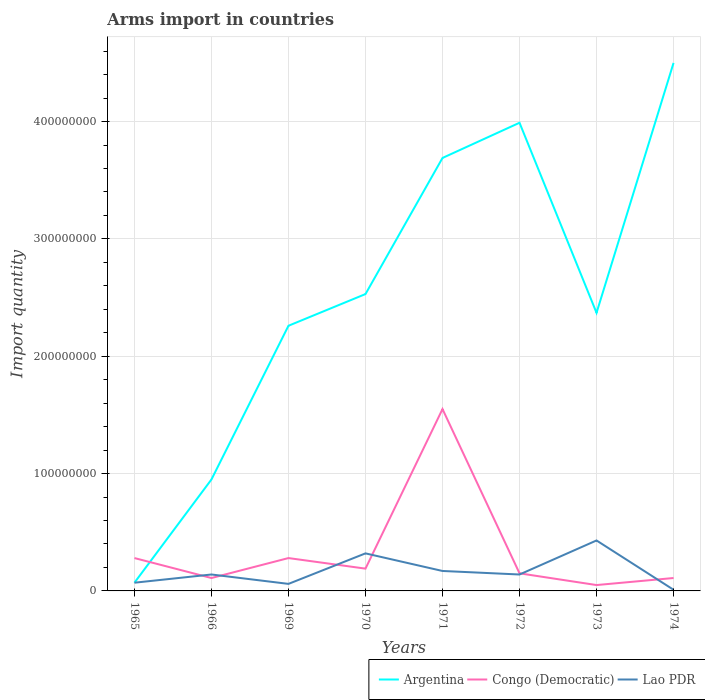Across all years, what is the maximum total arms import in Argentina?
Your answer should be very brief. 7.00e+06. In which year was the total arms import in Argentina maximum?
Your response must be concise. 1965. What is the total total arms import in Lao PDR in the graph?
Provide a succinct answer. -1.10e+07. What is the difference between the highest and the second highest total arms import in Argentina?
Provide a short and direct response. 4.43e+08. What is the difference between the highest and the lowest total arms import in Argentina?
Your answer should be very brief. 3. Is the total arms import in Congo (Democratic) strictly greater than the total arms import in Lao PDR over the years?
Your answer should be very brief. No. How many lines are there?
Offer a terse response. 3. How many years are there in the graph?
Your response must be concise. 8. What is the difference between two consecutive major ticks on the Y-axis?
Offer a terse response. 1.00e+08. Are the values on the major ticks of Y-axis written in scientific E-notation?
Your response must be concise. No. Where does the legend appear in the graph?
Offer a very short reply. Bottom right. What is the title of the graph?
Give a very brief answer. Arms import in countries. Does "Algeria" appear as one of the legend labels in the graph?
Provide a succinct answer. No. What is the label or title of the X-axis?
Offer a terse response. Years. What is the label or title of the Y-axis?
Ensure brevity in your answer.  Import quantity. What is the Import quantity in Congo (Democratic) in 1965?
Ensure brevity in your answer.  2.80e+07. What is the Import quantity in Argentina in 1966?
Offer a terse response. 9.50e+07. What is the Import quantity of Congo (Democratic) in 1966?
Your answer should be compact. 1.10e+07. What is the Import quantity of Lao PDR in 1966?
Your answer should be very brief. 1.40e+07. What is the Import quantity in Argentina in 1969?
Your response must be concise. 2.26e+08. What is the Import quantity of Congo (Democratic) in 1969?
Ensure brevity in your answer.  2.80e+07. What is the Import quantity of Lao PDR in 1969?
Your answer should be compact. 6.00e+06. What is the Import quantity in Argentina in 1970?
Provide a succinct answer. 2.53e+08. What is the Import quantity in Congo (Democratic) in 1970?
Your answer should be very brief. 1.90e+07. What is the Import quantity of Lao PDR in 1970?
Your response must be concise. 3.20e+07. What is the Import quantity in Argentina in 1971?
Offer a very short reply. 3.69e+08. What is the Import quantity in Congo (Democratic) in 1971?
Provide a succinct answer. 1.55e+08. What is the Import quantity of Lao PDR in 1971?
Your response must be concise. 1.70e+07. What is the Import quantity of Argentina in 1972?
Provide a short and direct response. 3.99e+08. What is the Import quantity in Congo (Democratic) in 1972?
Ensure brevity in your answer.  1.50e+07. What is the Import quantity in Lao PDR in 1972?
Keep it short and to the point. 1.40e+07. What is the Import quantity of Argentina in 1973?
Make the answer very short. 2.37e+08. What is the Import quantity in Congo (Democratic) in 1973?
Offer a very short reply. 5.00e+06. What is the Import quantity of Lao PDR in 1973?
Your answer should be very brief. 4.30e+07. What is the Import quantity in Argentina in 1974?
Ensure brevity in your answer.  4.50e+08. What is the Import quantity of Congo (Democratic) in 1974?
Make the answer very short. 1.10e+07. Across all years, what is the maximum Import quantity in Argentina?
Offer a terse response. 4.50e+08. Across all years, what is the maximum Import quantity of Congo (Democratic)?
Your answer should be compact. 1.55e+08. Across all years, what is the maximum Import quantity of Lao PDR?
Your answer should be compact. 4.30e+07. Across all years, what is the minimum Import quantity in Argentina?
Offer a terse response. 7.00e+06. Across all years, what is the minimum Import quantity in Congo (Democratic)?
Offer a very short reply. 5.00e+06. Across all years, what is the minimum Import quantity in Lao PDR?
Give a very brief answer. 1.00e+06. What is the total Import quantity in Argentina in the graph?
Offer a very short reply. 2.04e+09. What is the total Import quantity in Congo (Democratic) in the graph?
Offer a very short reply. 2.72e+08. What is the total Import quantity of Lao PDR in the graph?
Provide a succinct answer. 1.34e+08. What is the difference between the Import quantity of Argentina in 1965 and that in 1966?
Offer a very short reply. -8.80e+07. What is the difference between the Import quantity in Congo (Democratic) in 1965 and that in 1966?
Offer a very short reply. 1.70e+07. What is the difference between the Import quantity in Lao PDR in 1965 and that in 1966?
Offer a terse response. -7.00e+06. What is the difference between the Import quantity in Argentina in 1965 and that in 1969?
Your response must be concise. -2.19e+08. What is the difference between the Import quantity in Lao PDR in 1965 and that in 1969?
Give a very brief answer. 1.00e+06. What is the difference between the Import quantity in Argentina in 1965 and that in 1970?
Your answer should be very brief. -2.46e+08. What is the difference between the Import quantity of Congo (Democratic) in 1965 and that in 1970?
Offer a very short reply. 9.00e+06. What is the difference between the Import quantity of Lao PDR in 1965 and that in 1970?
Your answer should be compact. -2.50e+07. What is the difference between the Import quantity of Argentina in 1965 and that in 1971?
Provide a succinct answer. -3.62e+08. What is the difference between the Import quantity in Congo (Democratic) in 1965 and that in 1971?
Provide a succinct answer. -1.27e+08. What is the difference between the Import quantity in Lao PDR in 1965 and that in 1971?
Your answer should be very brief. -1.00e+07. What is the difference between the Import quantity of Argentina in 1965 and that in 1972?
Offer a very short reply. -3.92e+08. What is the difference between the Import quantity of Congo (Democratic) in 1965 and that in 1972?
Your answer should be very brief. 1.30e+07. What is the difference between the Import quantity of Lao PDR in 1965 and that in 1972?
Your answer should be very brief. -7.00e+06. What is the difference between the Import quantity in Argentina in 1965 and that in 1973?
Your answer should be very brief. -2.30e+08. What is the difference between the Import quantity of Congo (Democratic) in 1965 and that in 1973?
Your answer should be compact. 2.30e+07. What is the difference between the Import quantity in Lao PDR in 1965 and that in 1973?
Offer a very short reply. -3.60e+07. What is the difference between the Import quantity in Argentina in 1965 and that in 1974?
Provide a short and direct response. -4.43e+08. What is the difference between the Import quantity in Congo (Democratic) in 1965 and that in 1974?
Your answer should be compact. 1.70e+07. What is the difference between the Import quantity in Argentina in 1966 and that in 1969?
Give a very brief answer. -1.31e+08. What is the difference between the Import quantity of Congo (Democratic) in 1966 and that in 1969?
Your answer should be very brief. -1.70e+07. What is the difference between the Import quantity of Lao PDR in 1966 and that in 1969?
Give a very brief answer. 8.00e+06. What is the difference between the Import quantity of Argentina in 1966 and that in 1970?
Give a very brief answer. -1.58e+08. What is the difference between the Import quantity of Congo (Democratic) in 1966 and that in 1970?
Your answer should be compact. -8.00e+06. What is the difference between the Import quantity in Lao PDR in 1966 and that in 1970?
Give a very brief answer. -1.80e+07. What is the difference between the Import quantity in Argentina in 1966 and that in 1971?
Make the answer very short. -2.74e+08. What is the difference between the Import quantity of Congo (Democratic) in 1966 and that in 1971?
Make the answer very short. -1.44e+08. What is the difference between the Import quantity in Argentina in 1966 and that in 1972?
Offer a terse response. -3.04e+08. What is the difference between the Import quantity in Congo (Democratic) in 1966 and that in 1972?
Your answer should be very brief. -4.00e+06. What is the difference between the Import quantity of Argentina in 1966 and that in 1973?
Make the answer very short. -1.42e+08. What is the difference between the Import quantity in Congo (Democratic) in 1966 and that in 1973?
Make the answer very short. 6.00e+06. What is the difference between the Import quantity of Lao PDR in 1966 and that in 1973?
Provide a succinct answer. -2.90e+07. What is the difference between the Import quantity in Argentina in 1966 and that in 1974?
Your answer should be very brief. -3.55e+08. What is the difference between the Import quantity of Congo (Democratic) in 1966 and that in 1974?
Your answer should be very brief. 0. What is the difference between the Import quantity in Lao PDR in 1966 and that in 1974?
Your answer should be compact. 1.30e+07. What is the difference between the Import quantity of Argentina in 1969 and that in 1970?
Your answer should be compact. -2.70e+07. What is the difference between the Import quantity in Congo (Democratic) in 1969 and that in 1970?
Provide a succinct answer. 9.00e+06. What is the difference between the Import quantity of Lao PDR in 1969 and that in 1970?
Offer a very short reply. -2.60e+07. What is the difference between the Import quantity of Argentina in 1969 and that in 1971?
Offer a very short reply. -1.43e+08. What is the difference between the Import quantity in Congo (Democratic) in 1969 and that in 1971?
Your answer should be compact. -1.27e+08. What is the difference between the Import quantity in Lao PDR in 1969 and that in 1971?
Offer a very short reply. -1.10e+07. What is the difference between the Import quantity in Argentina in 1969 and that in 1972?
Offer a terse response. -1.73e+08. What is the difference between the Import quantity in Congo (Democratic) in 1969 and that in 1972?
Give a very brief answer. 1.30e+07. What is the difference between the Import quantity in Lao PDR in 1969 and that in 1972?
Offer a very short reply. -8.00e+06. What is the difference between the Import quantity of Argentina in 1969 and that in 1973?
Keep it short and to the point. -1.10e+07. What is the difference between the Import quantity of Congo (Democratic) in 1969 and that in 1973?
Provide a succinct answer. 2.30e+07. What is the difference between the Import quantity in Lao PDR in 1969 and that in 1973?
Your response must be concise. -3.70e+07. What is the difference between the Import quantity in Argentina in 1969 and that in 1974?
Your answer should be compact. -2.24e+08. What is the difference between the Import quantity in Congo (Democratic) in 1969 and that in 1974?
Your answer should be very brief. 1.70e+07. What is the difference between the Import quantity of Lao PDR in 1969 and that in 1974?
Offer a very short reply. 5.00e+06. What is the difference between the Import quantity in Argentina in 1970 and that in 1971?
Make the answer very short. -1.16e+08. What is the difference between the Import quantity of Congo (Democratic) in 1970 and that in 1971?
Your answer should be compact. -1.36e+08. What is the difference between the Import quantity of Lao PDR in 1970 and that in 1971?
Provide a succinct answer. 1.50e+07. What is the difference between the Import quantity of Argentina in 1970 and that in 1972?
Provide a short and direct response. -1.46e+08. What is the difference between the Import quantity of Congo (Democratic) in 1970 and that in 1972?
Give a very brief answer. 4.00e+06. What is the difference between the Import quantity in Lao PDR in 1970 and that in 1972?
Keep it short and to the point. 1.80e+07. What is the difference between the Import quantity of Argentina in 1970 and that in 1973?
Your response must be concise. 1.60e+07. What is the difference between the Import quantity of Congo (Democratic) in 1970 and that in 1973?
Your answer should be very brief. 1.40e+07. What is the difference between the Import quantity of Lao PDR in 1970 and that in 1973?
Offer a terse response. -1.10e+07. What is the difference between the Import quantity of Argentina in 1970 and that in 1974?
Give a very brief answer. -1.97e+08. What is the difference between the Import quantity of Congo (Democratic) in 1970 and that in 1974?
Keep it short and to the point. 8.00e+06. What is the difference between the Import quantity of Lao PDR in 1970 and that in 1974?
Make the answer very short. 3.10e+07. What is the difference between the Import quantity in Argentina in 1971 and that in 1972?
Offer a terse response. -3.00e+07. What is the difference between the Import quantity in Congo (Democratic) in 1971 and that in 1972?
Ensure brevity in your answer.  1.40e+08. What is the difference between the Import quantity of Argentina in 1971 and that in 1973?
Give a very brief answer. 1.32e+08. What is the difference between the Import quantity of Congo (Democratic) in 1971 and that in 1973?
Your answer should be compact. 1.50e+08. What is the difference between the Import quantity of Lao PDR in 1971 and that in 1973?
Provide a short and direct response. -2.60e+07. What is the difference between the Import quantity in Argentina in 1971 and that in 1974?
Your answer should be compact. -8.10e+07. What is the difference between the Import quantity of Congo (Democratic) in 1971 and that in 1974?
Your answer should be very brief. 1.44e+08. What is the difference between the Import quantity in Lao PDR in 1971 and that in 1974?
Your answer should be compact. 1.60e+07. What is the difference between the Import quantity of Argentina in 1972 and that in 1973?
Your answer should be very brief. 1.62e+08. What is the difference between the Import quantity of Lao PDR in 1972 and that in 1973?
Offer a very short reply. -2.90e+07. What is the difference between the Import quantity in Argentina in 1972 and that in 1974?
Your answer should be very brief. -5.10e+07. What is the difference between the Import quantity of Lao PDR in 1972 and that in 1974?
Keep it short and to the point. 1.30e+07. What is the difference between the Import quantity in Argentina in 1973 and that in 1974?
Give a very brief answer. -2.13e+08. What is the difference between the Import quantity in Congo (Democratic) in 1973 and that in 1974?
Provide a short and direct response. -6.00e+06. What is the difference between the Import quantity in Lao PDR in 1973 and that in 1974?
Offer a very short reply. 4.20e+07. What is the difference between the Import quantity of Argentina in 1965 and the Import quantity of Congo (Democratic) in 1966?
Give a very brief answer. -4.00e+06. What is the difference between the Import quantity in Argentina in 1965 and the Import quantity in Lao PDR in 1966?
Provide a short and direct response. -7.00e+06. What is the difference between the Import quantity of Congo (Democratic) in 1965 and the Import quantity of Lao PDR in 1966?
Your answer should be very brief. 1.40e+07. What is the difference between the Import quantity in Argentina in 1965 and the Import quantity in Congo (Democratic) in 1969?
Your response must be concise. -2.10e+07. What is the difference between the Import quantity in Argentina in 1965 and the Import quantity in Lao PDR in 1969?
Keep it short and to the point. 1.00e+06. What is the difference between the Import quantity of Congo (Democratic) in 1965 and the Import quantity of Lao PDR in 1969?
Your answer should be compact. 2.20e+07. What is the difference between the Import quantity of Argentina in 1965 and the Import quantity of Congo (Democratic) in 1970?
Keep it short and to the point. -1.20e+07. What is the difference between the Import quantity in Argentina in 1965 and the Import quantity in Lao PDR in 1970?
Your response must be concise. -2.50e+07. What is the difference between the Import quantity in Argentina in 1965 and the Import quantity in Congo (Democratic) in 1971?
Provide a short and direct response. -1.48e+08. What is the difference between the Import quantity in Argentina in 1965 and the Import quantity in Lao PDR in 1971?
Your answer should be very brief. -1.00e+07. What is the difference between the Import quantity of Congo (Democratic) in 1965 and the Import quantity of Lao PDR in 1971?
Provide a short and direct response. 1.10e+07. What is the difference between the Import quantity in Argentina in 1965 and the Import quantity in Congo (Democratic) in 1972?
Give a very brief answer. -8.00e+06. What is the difference between the Import quantity in Argentina in 1965 and the Import quantity in Lao PDR in 1972?
Give a very brief answer. -7.00e+06. What is the difference between the Import quantity in Congo (Democratic) in 1965 and the Import quantity in Lao PDR in 1972?
Keep it short and to the point. 1.40e+07. What is the difference between the Import quantity of Argentina in 1965 and the Import quantity of Lao PDR in 1973?
Ensure brevity in your answer.  -3.60e+07. What is the difference between the Import quantity in Congo (Democratic) in 1965 and the Import quantity in Lao PDR in 1973?
Make the answer very short. -1.50e+07. What is the difference between the Import quantity of Congo (Democratic) in 1965 and the Import quantity of Lao PDR in 1974?
Your response must be concise. 2.70e+07. What is the difference between the Import quantity in Argentina in 1966 and the Import quantity in Congo (Democratic) in 1969?
Provide a succinct answer. 6.70e+07. What is the difference between the Import quantity in Argentina in 1966 and the Import quantity in Lao PDR in 1969?
Offer a terse response. 8.90e+07. What is the difference between the Import quantity of Argentina in 1966 and the Import quantity of Congo (Democratic) in 1970?
Give a very brief answer. 7.60e+07. What is the difference between the Import quantity in Argentina in 1966 and the Import quantity in Lao PDR in 1970?
Offer a terse response. 6.30e+07. What is the difference between the Import quantity in Congo (Democratic) in 1966 and the Import quantity in Lao PDR in 1970?
Offer a very short reply. -2.10e+07. What is the difference between the Import quantity of Argentina in 1966 and the Import quantity of Congo (Democratic) in 1971?
Your response must be concise. -6.00e+07. What is the difference between the Import quantity in Argentina in 1966 and the Import quantity in Lao PDR in 1971?
Make the answer very short. 7.80e+07. What is the difference between the Import quantity of Congo (Democratic) in 1966 and the Import quantity of Lao PDR in 1971?
Offer a terse response. -6.00e+06. What is the difference between the Import quantity of Argentina in 1966 and the Import quantity of Congo (Democratic) in 1972?
Offer a terse response. 8.00e+07. What is the difference between the Import quantity of Argentina in 1966 and the Import quantity of Lao PDR in 1972?
Keep it short and to the point. 8.10e+07. What is the difference between the Import quantity of Congo (Democratic) in 1966 and the Import quantity of Lao PDR in 1972?
Ensure brevity in your answer.  -3.00e+06. What is the difference between the Import quantity of Argentina in 1966 and the Import quantity of Congo (Democratic) in 1973?
Offer a very short reply. 9.00e+07. What is the difference between the Import quantity of Argentina in 1966 and the Import quantity of Lao PDR in 1973?
Provide a short and direct response. 5.20e+07. What is the difference between the Import quantity in Congo (Democratic) in 1966 and the Import quantity in Lao PDR in 1973?
Make the answer very short. -3.20e+07. What is the difference between the Import quantity in Argentina in 1966 and the Import quantity in Congo (Democratic) in 1974?
Your response must be concise. 8.40e+07. What is the difference between the Import quantity in Argentina in 1966 and the Import quantity in Lao PDR in 1974?
Ensure brevity in your answer.  9.40e+07. What is the difference between the Import quantity in Argentina in 1969 and the Import quantity in Congo (Democratic) in 1970?
Your response must be concise. 2.07e+08. What is the difference between the Import quantity in Argentina in 1969 and the Import quantity in Lao PDR in 1970?
Give a very brief answer. 1.94e+08. What is the difference between the Import quantity of Argentina in 1969 and the Import quantity of Congo (Democratic) in 1971?
Offer a very short reply. 7.10e+07. What is the difference between the Import quantity in Argentina in 1969 and the Import quantity in Lao PDR in 1971?
Give a very brief answer. 2.09e+08. What is the difference between the Import quantity of Congo (Democratic) in 1969 and the Import quantity of Lao PDR in 1971?
Keep it short and to the point. 1.10e+07. What is the difference between the Import quantity of Argentina in 1969 and the Import quantity of Congo (Democratic) in 1972?
Ensure brevity in your answer.  2.11e+08. What is the difference between the Import quantity in Argentina in 1969 and the Import quantity in Lao PDR in 1972?
Give a very brief answer. 2.12e+08. What is the difference between the Import quantity in Congo (Democratic) in 1969 and the Import quantity in Lao PDR in 1972?
Your response must be concise. 1.40e+07. What is the difference between the Import quantity in Argentina in 1969 and the Import quantity in Congo (Democratic) in 1973?
Provide a short and direct response. 2.21e+08. What is the difference between the Import quantity in Argentina in 1969 and the Import quantity in Lao PDR in 1973?
Provide a short and direct response. 1.83e+08. What is the difference between the Import quantity of Congo (Democratic) in 1969 and the Import quantity of Lao PDR in 1973?
Ensure brevity in your answer.  -1.50e+07. What is the difference between the Import quantity in Argentina in 1969 and the Import quantity in Congo (Democratic) in 1974?
Your answer should be compact. 2.15e+08. What is the difference between the Import quantity in Argentina in 1969 and the Import quantity in Lao PDR in 1974?
Ensure brevity in your answer.  2.25e+08. What is the difference between the Import quantity in Congo (Democratic) in 1969 and the Import quantity in Lao PDR in 1974?
Ensure brevity in your answer.  2.70e+07. What is the difference between the Import quantity in Argentina in 1970 and the Import quantity in Congo (Democratic) in 1971?
Your answer should be compact. 9.80e+07. What is the difference between the Import quantity of Argentina in 1970 and the Import quantity of Lao PDR in 1971?
Offer a terse response. 2.36e+08. What is the difference between the Import quantity of Argentina in 1970 and the Import quantity of Congo (Democratic) in 1972?
Your response must be concise. 2.38e+08. What is the difference between the Import quantity of Argentina in 1970 and the Import quantity of Lao PDR in 1972?
Your answer should be very brief. 2.39e+08. What is the difference between the Import quantity in Argentina in 1970 and the Import quantity in Congo (Democratic) in 1973?
Give a very brief answer. 2.48e+08. What is the difference between the Import quantity in Argentina in 1970 and the Import quantity in Lao PDR in 1973?
Ensure brevity in your answer.  2.10e+08. What is the difference between the Import quantity in Congo (Democratic) in 1970 and the Import quantity in Lao PDR in 1973?
Your response must be concise. -2.40e+07. What is the difference between the Import quantity of Argentina in 1970 and the Import quantity of Congo (Democratic) in 1974?
Offer a terse response. 2.42e+08. What is the difference between the Import quantity in Argentina in 1970 and the Import quantity in Lao PDR in 1974?
Provide a succinct answer. 2.52e+08. What is the difference between the Import quantity of Congo (Democratic) in 1970 and the Import quantity of Lao PDR in 1974?
Ensure brevity in your answer.  1.80e+07. What is the difference between the Import quantity of Argentina in 1971 and the Import quantity of Congo (Democratic) in 1972?
Your answer should be compact. 3.54e+08. What is the difference between the Import quantity of Argentina in 1971 and the Import quantity of Lao PDR in 1972?
Ensure brevity in your answer.  3.55e+08. What is the difference between the Import quantity of Congo (Democratic) in 1971 and the Import quantity of Lao PDR in 1972?
Provide a short and direct response. 1.41e+08. What is the difference between the Import quantity in Argentina in 1971 and the Import quantity in Congo (Democratic) in 1973?
Give a very brief answer. 3.64e+08. What is the difference between the Import quantity in Argentina in 1971 and the Import quantity in Lao PDR in 1973?
Give a very brief answer. 3.26e+08. What is the difference between the Import quantity in Congo (Democratic) in 1971 and the Import quantity in Lao PDR in 1973?
Make the answer very short. 1.12e+08. What is the difference between the Import quantity of Argentina in 1971 and the Import quantity of Congo (Democratic) in 1974?
Make the answer very short. 3.58e+08. What is the difference between the Import quantity in Argentina in 1971 and the Import quantity in Lao PDR in 1974?
Keep it short and to the point. 3.68e+08. What is the difference between the Import quantity in Congo (Democratic) in 1971 and the Import quantity in Lao PDR in 1974?
Provide a short and direct response. 1.54e+08. What is the difference between the Import quantity of Argentina in 1972 and the Import quantity of Congo (Democratic) in 1973?
Provide a succinct answer. 3.94e+08. What is the difference between the Import quantity in Argentina in 1972 and the Import quantity in Lao PDR in 1973?
Your answer should be compact. 3.56e+08. What is the difference between the Import quantity of Congo (Democratic) in 1972 and the Import quantity of Lao PDR in 1973?
Your answer should be compact. -2.80e+07. What is the difference between the Import quantity of Argentina in 1972 and the Import quantity of Congo (Democratic) in 1974?
Provide a short and direct response. 3.88e+08. What is the difference between the Import quantity in Argentina in 1972 and the Import quantity in Lao PDR in 1974?
Provide a succinct answer. 3.98e+08. What is the difference between the Import quantity of Congo (Democratic) in 1972 and the Import quantity of Lao PDR in 1974?
Keep it short and to the point. 1.40e+07. What is the difference between the Import quantity in Argentina in 1973 and the Import quantity in Congo (Democratic) in 1974?
Your answer should be very brief. 2.26e+08. What is the difference between the Import quantity of Argentina in 1973 and the Import quantity of Lao PDR in 1974?
Provide a succinct answer. 2.36e+08. What is the difference between the Import quantity in Congo (Democratic) in 1973 and the Import quantity in Lao PDR in 1974?
Offer a terse response. 4.00e+06. What is the average Import quantity in Argentina per year?
Provide a short and direct response. 2.54e+08. What is the average Import quantity of Congo (Democratic) per year?
Offer a very short reply. 3.40e+07. What is the average Import quantity in Lao PDR per year?
Your answer should be compact. 1.68e+07. In the year 1965, what is the difference between the Import quantity of Argentina and Import quantity of Congo (Democratic)?
Make the answer very short. -2.10e+07. In the year 1965, what is the difference between the Import quantity in Congo (Democratic) and Import quantity in Lao PDR?
Provide a succinct answer. 2.10e+07. In the year 1966, what is the difference between the Import quantity in Argentina and Import quantity in Congo (Democratic)?
Offer a terse response. 8.40e+07. In the year 1966, what is the difference between the Import quantity of Argentina and Import quantity of Lao PDR?
Give a very brief answer. 8.10e+07. In the year 1966, what is the difference between the Import quantity in Congo (Democratic) and Import quantity in Lao PDR?
Provide a short and direct response. -3.00e+06. In the year 1969, what is the difference between the Import quantity of Argentina and Import quantity of Congo (Democratic)?
Make the answer very short. 1.98e+08. In the year 1969, what is the difference between the Import quantity in Argentina and Import quantity in Lao PDR?
Provide a short and direct response. 2.20e+08. In the year 1969, what is the difference between the Import quantity in Congo (Democratic) and Import quantity in Lao PDR?
Keep it short and to the point. 2.20e+07. In the year 1970, what is the difference between the Import quantity in Argentina and Import quantity in Congo (Democratic)?
Keep it short and to the point. 2.34e+08. In the year 1970, what is the difference between the Import quantity of Argentina and Import quantity of Lao PDR?
Offer a very short reply. 2.21e+08. In the year 1970, what is the difference between the Import quantity of Congo (Democratic) and Import quantity of Lao PDR?
Your response must be concise. -1.30e+07. In the year 1971, what is the difference between the Import quantity in Argentina and Import quantity in Congo (Democratic)?
Your answer should be very brief. 2.14e+08. In the year 1971, what is the difference between the Import quantity of Argentina and Import quantity of Lao PDR?
Your answer should be very brief. 3.52e+08. In the year 1971, what is the difference between the Import quantity in Congo (Democratic) and Import quantity in Lao PDR?
Make the answer very short. 1.38e+08. In the year 1972, what is the difference between the Import quantity in Argentina and Import quantity in Congo (Democratic)?
Ensure brevity in your answer.  3.84e+08. In the year 1972, what is the difference between the Import quantity of Argentina and Import quantity of Lao PDR?
Your response must be concise. 3.85e+08. In the year 1972, what is the difference between the Import quantity in Congo (Democratic) and Import quantity in Lao PDR?
Offer a very short reply. 1.00e+06. In the year 1973, what is the difference between the Import quantity in Argentina and Import quantity in Congo (Democratic)?
Make the answer very short. 2.32e+08. In the year 1973, what is the difference between the Import quantity of Argentina and Import quantity of Lao PDR?
Keep it short and to the point. 1.94e+08. In the year 1973, what is the difference between the Import quantity of Congo (Democratic) and Import quantity of Lao PDR?
Provide a succinct answer. -3.80e+07. In the year 1974, what is the difference between the Import quantity in Argentina and Import quantity in Congo (Democratic)?
Ensure brevity in your answer.  4.39e+08. In the year 1974, what is the difference between the Import quantity of Argentina and Import quantity of Lao PDR?
Offer a very short reply. 4.49e+08. What is the ratio of the Import quantity of Argentina in 1965 to that in 1966?
Keep it short and to the point. 0.07. What is the ratio of the Import quantity of Congo (Democratic) in 1965 to that in 1966?
Give a very brief answer. 2.55. What is the ratio of the Import quantity of Lao PDR in 1965 to that in 1966?
Make the answer very short. 0.5. What is the ratio of the Import quantity of Argentina in 1965 to that in 1969?
Your answer should be compact. 0.03. What is the ratio of the Import quantity of Congo (Democratic) in 1965 to that in 1969?
Provide a short and direct response. 1. What is the ratio of the Import quantity in Argentina in 1965 to that in 1970?
Keep it short and to the point. 0.03. What is the ratio of the Import quantity in Congo (Democratic) in 1965 to that in 1970?
Give a very brief answer. 1.47. What is the ratio of the Import quantity in Lao PDR in 1965 to that in 1970?
Offer a very short reply. 0.22. What is the ratio of the Import quantity in Argentina in 1965 to that in 1971?
Your answer should be very brief. 0.02. What is the ratio of the Import quantity in Congo (Democratic) in 1965 to that in 1971?
Make the answer very short. 0.18. What is the ratio of the Import quantity in Lao PDR in 1965 to that in 1971?
Offer a terse response. 0.41. What is the ratio of the Import quantity in Argentina in 1965 to that in 1972?
Offer a terse response. 0.02. What is the ratio of the Import quantity in Congo (Democratic) in 1965 to that in 1972?
Offer a very short reply. 1.87. What is the ratio of the Import quantity of Argentina in 1965 to that in 1973?
Your answer should be compact. 0.03. What is the ratio of the Import quantity of Lao PDR in 1965 to that in 1973?
Ensure brevity in your answer.  0.16. What is the ratio of the Import quantity of Argentina in 1965 to that in 1974?
Offer a very short reply. 0.02. What is the ratio of the Import quantity of Congo (Democratic) in 1965 to that in 1974?
Provide a succinct answer. 2.55. What is the ratio of the Import quantity of Argentina in 1966 to that in 1969?
Offer a very short reply. 0.42. What is the ratio of the Import quantity in Congo (Democratic) in 1966 to that in 1969?
Ensure brevity in your answer.  0.39. What is the ratio of the Import quantity of Lao PDR in 1966 to that in 1969?
Keep it short and to the point. 2.33. What is the ratio of the Import quantity of Argentina in 1966 to that in 1970?
Ensure brevity in your answer.  0.38. What is the ratio of the Import quantity in Congo (Democratic) in 1966 to that in 1970?
Keep it short and to the point. 0.58. What is the ratio of the Import quantity of Lao PDR in 1966 to that in 1970?
Give a very brief answer. 0.44. What is the ratio of the Import quantity of Argentina in 1966 to that in 1971?
Provide a short and direct response. 0.26. What is the ratio of the Import quantity of Congo (Democratic) in 1966 to that in 1971?
Your response must be concise. 0.07. What is the ratio of the Import quantity of Lao PDR in 1966 to that in 1971?
Offer a terse response. 0.82. What is the ratio of the Import quantity of Argentina in 1966 to that in 1972?
Offer a terse response. 0.24. What is the ratio of the Import quantity in Congo (Democratic) in 1966 to that in 1972?
Your answer should be very brief. 0.73. What is the ratio of the Import quantity in Lao PDR in 1966 to that in 1972?
Make the answer very short. 1. What is the ratio of the Import quantity in Argentina in 1966 to that in 1973?
Offer a terse response. 0.4. What is the ratio of the Import quantity in Congo (Democratic) in 1966 to that in 1973?
Your response must be concise. 2.2. What is the ratio of the Import quantity in Lao PDR in 1966 to that in 1973?
Your answer should be compact. 0.33. What is the ratio of the Import quantity of Argentina in 1966 to that in 1974?
Ensure brevity in your answer.  0.21. What is the ratio of the Import quantity of Congo (Democratic) in 1966 to that in 1974?
Make the answer very short. 1. What is the ratio of the Import quantity of Lao PDR in 1966 to that in 1974?
Your response must be concise. 14. What is the ratio of the Import quantity of Argentina in 1969 to that in 1970?
Offer a terse response. 0.89. What is the ratio of the Import quantity of Congo (Democratic) in 1969 to that in 1970?
Provide a short and direct response. 1.47. What is the ratio of the Import quantity in Lao PDR in 1969 to that in 1970?
Your answer should be compact. 0.19. What is the ratio of the Import quantity in Argentina in 1969 to that in 1971?
Keep it short and to the point. 0.61. What is the ratio of the Import quantity in Congo (Democratic) in 1969 to that in 1971?
Ensure brevity in your answer.  0.18. What is the ratio of the Import quantity in Lao PDR in 1969 to that in 1971?
Offer a very short reply. 0.35. What is the ratio of the Import quantity in Argentina in 1969 to that in 1972?
Your answer should be compact. 0.57. What is the ratio of the Import quantity in Congo (Democratic) in 1969 to that in 1972?
Keep it short and to the point. 1.87. What is the ratio of the Import quantity of Lao PDR in 1969 to that in 1972?
Ensure brevity in your answer.  0.43. What is the ratio of the Import quantity of Argentina in 1969 to that in 1973?
Your answer should be very brief. 0.95. What is the ratio of the Import quantity of Congo (Democratic) in 1969 to that in 1973?
Your answer should be very brief. 5.6. What is the ratio of the Import quantity of Lao PDR in 1969 to that in 1973?
Give a very brief answer. 0.14. What is the ratio of the Import quantity of Argentina in 1969 to that in 1974?
Provide a short and direct response. 0.5. What is the ratio of the Import quantity in Congo (Democratic) in 1969 to that in 1974?
Provide a short and direct response. 2.55. What is the ratio of the Import quantity in Lao PDR in 1969 to that in 1974?
Ensure brevity in your answer.  6. What is the ratio of the Import quantity of Argentina in 1970 to that in 1971?
Give a very brief answer. 0.69. What is the ratio of the Import quantity of Congo (Democratic) in 1970 to that in 1971?
Give a very brief answer. 0.12. What is the ratio of the Import quantity in Lao PDR in 1970 to that in 1971?
Keep it short and to the point. 1.88. What is the ratio of the Import quantity in Argentina in 1970 to that in 1972?
Give a very brief answer. 0.63. What is the ratio of the Import quantity in Congo (Democratic) in 1970 to that in 1972?
Ensure brevity in your answer.  1.27. What is the ratio of the Import quantity in Lao PDR in 1970 to that in 1972?
Your answer should be compact. 2.29. What is the ratio of the Import quantity in Argentina in 1970 to that in 1973?
Provide a short and direct response. 1.07. What is the ratio of the Import quantity of Congo (Democratic) in 1970 to that in 1973?
Provide a succinct answer. 3.8. What is the ratio of the Import quantity of Lao PDR in 1970 to that in 1973?
Provide a succinct answer. 0.74. What is the ratio of the Import quantity in Argentina in 1970 to that in 1974?
Provide a succinct answer. 0.56. What is the ratio of the Import quantity of Congo (Democratic) in 1970 to that in 1974?
Provide a short and direct response. 1.73. What is the ratio of the Import quantity of Argentina in 1971 to that in 1972?
Give a very brief answer. 0.92. What is the ratio of the Import quantity in Congo (Democratic) in 1971 to that in 1972?
Keep it short and to the point. 10.33. What is the ratio of the Import quantity of Lao PDR in 1971 to that in 1972?
Keep it short and to the point. 1.21. What is the ratio of the Import quantity of Argentina in 1971 to that in 1973?
Your answer should be compact. 1.56. What is the ratio of the Import quantity in Congo (Democratic) in 1971 to that in 1973?
Give a very brief answer. 31. What is the ratio of the Import quantity of Lao PDR in 1971 to that in 1973?
Offer a very short reply. 0.4. What is the ratio of the Import quantity of Argentina in 1971 to that in 1974?
Provide a short and direct response. 0.82. What is the ratio of the Import quantity in Congo (Democratic) in 1971 to that in 1974?
Make the answer very short. 14.09. What is the ratio of the Import quantity in Lao PDR in 1971 to that in 1974?
Ensure brevity in your answer.  17. What is the ratio of the Import quantity in Argentina in 1972 to that in 1973?
Your response must be concise. 1.68. What is the ratio of the Import quantity in Lao PDR in 1972 to that in 1973?
Provide a short and direct response. 0.33. What is the ratio of the Import quantity of Argentina in 1972 to that in 1974?
Give a very brief answer. 0.89. What is the ratio of the Import quantity of Congo (Democratic) in 1972 to that in 1974?
Make the answer very short. 1.36. What is the ratio of the Import quantity of Lao PDR in 1972 to that in 1974?
Your answer should be compact. 14. What is the ratio of the Import quantity of Argentina in 1973 to that in 1974?
Ensure brevity in your answer.  0.53. What is the ratio of the Import quantity in Congo (Democratic) in 1973 to that in 1974?
Provide a succinct answer. 0.45. What is the difference between the highest and the second highest Import quantity in Argentina?
Your answer should be compact. 5.10e+07. What is the difference between the highest and the second highest Import quantity of Congo (Democratic)?
Offer a very short reply. 1.27e+08. What is the difference between the highest and the second highest Import quantity of Lao PDR?
Offer a terse response. 1.10e+07. What is the difference between the highest and the lowest Import quantity of Argentina?
Your answer should be compact. 4.43e+08. What is the difference between the highest and the lowest Import quantity of Congo (Democratic)?
Provide a short and direct response. 1.50e+08. What is the difference between the highest and the lowest Import quantity of Lao PDR?
Provide a short and direct response. 4.20e+07. 